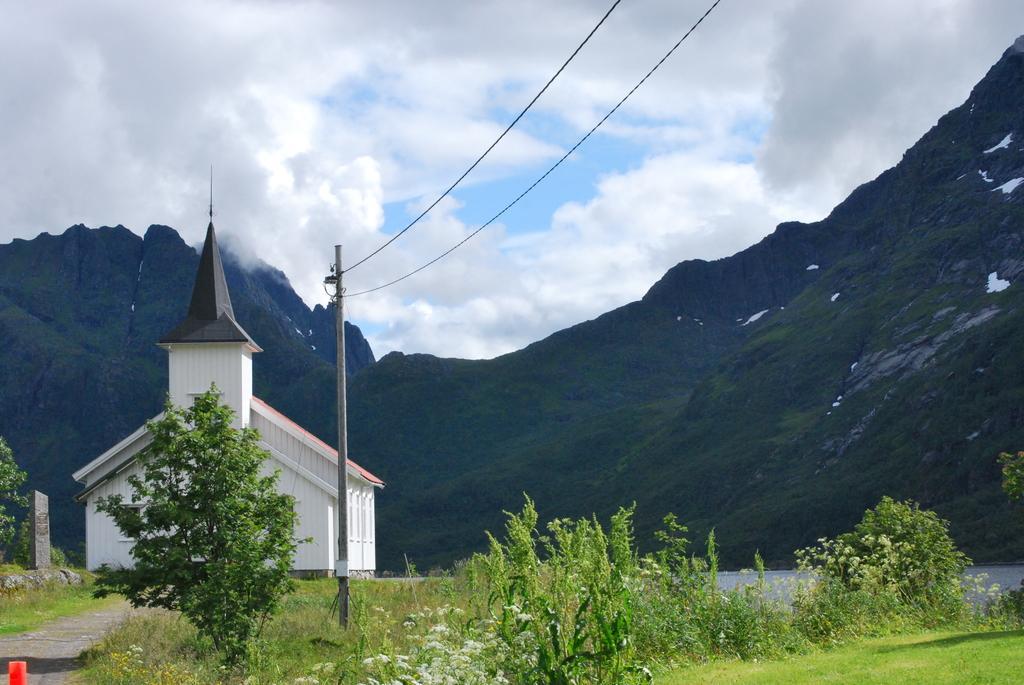Could you give a brief overview of what you see in this image? In this picture I can see the grass and plants in front. In the middle of this picture I can see a building, a pole on which there are 2 wires and I can see the hills. In the background I can see the sky, which is a bit cloudy. On the left bottom corner of this picture, I can see a red color thing. 